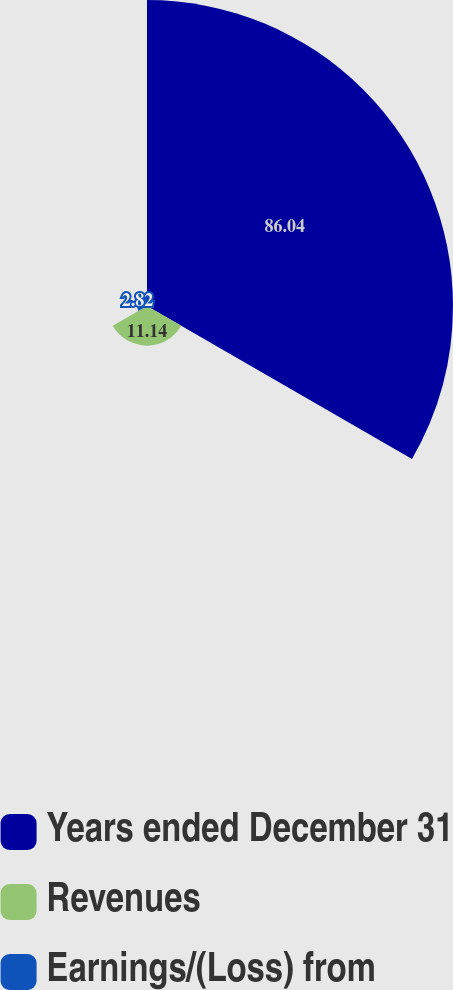Convert chart. <chart><loc_0><loc_0><loc_500><loc_500><pie_chart><fcel>Years ended December 31<fcel>Revenues<fcel>Earnings/(Loss) from<nl><fcel>86.03%<fcel>11.14%<fcel>2.82%<nl></chart> 